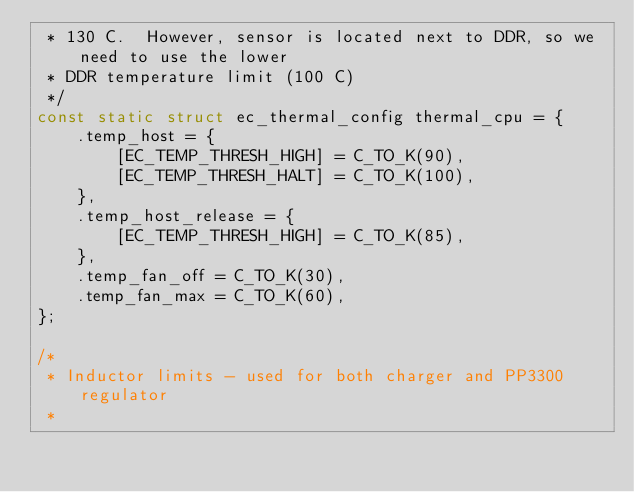<code> <loc_0><loc_0><loc_500><loc_500><_C_> * 130 C.  However, sensor is located next to DDR, so we need to use the lower
 * DDR temperature limit (100 C)
 */
const static struct ec_thermal_config thermal_cpu = {
	.temp_host = {
		[EC_TEMP_THRESH_HIGH] = C_TO_K(90),
		[EC_TEMP_THRESH_HALT] = C_TO_K(100),
	},
	.temp_host_release = {
		[EC_TEMP_THRESH_HIGH] = C_TO_K(85),
	},
	.temp_fan_off = C_TO_K(30),
	.temp_fan_max = C_TO_K(60),
};

/*
 * Inductor limits - used for both charger and PP3300 regulator
 *</code> 